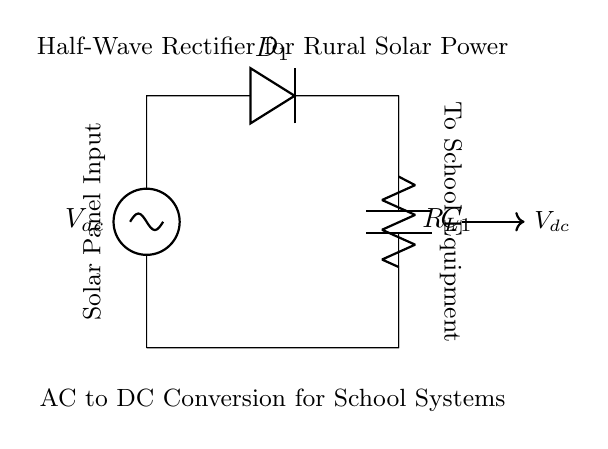What type of rectifier is this circuit? The diagram shows a half-wave rectifier because it allows only one polarity of the input AC voltage to pass through while blocking the other half.
Answer: Half-wave rectifier What is the role of the diode in this circuit? The diode (D1) in the circuit serves to allow current to flow in only one direction, converting the AC input to a pulsed DC output.
Answer: To allow current in one direction What component is used to smooth the output voltage? The capacitor (C1) is used to smooth the output voltage by charging during the peaks of the pulsed DC and discharging when the voltage drops, thus reducing ripples.
Answer: Capacitor What is the function of the load resistor in this circuit? The load resistor (R_L) represents the school equipment that will consume the DC power provided by the circuit and helps in drawing current from the output.
Answer: To represent load What happens to the output voltage if the AC input voltage increases? If the AC input voltage increases, the peak voltage of the output DC will also increase proportionally, as the output will be a function of the input voltage minus the forward voltage drop of the diode.
Answer: Increases output voltage How does the half-wave rectifier affect energy efficiency? A half-wave rectifier is less efficient than a full-wave rectifier because it only uses one half of the input AC waveform, leading to lower average output voltage and power efficiency.
Answer: Less efficient energy conversion 